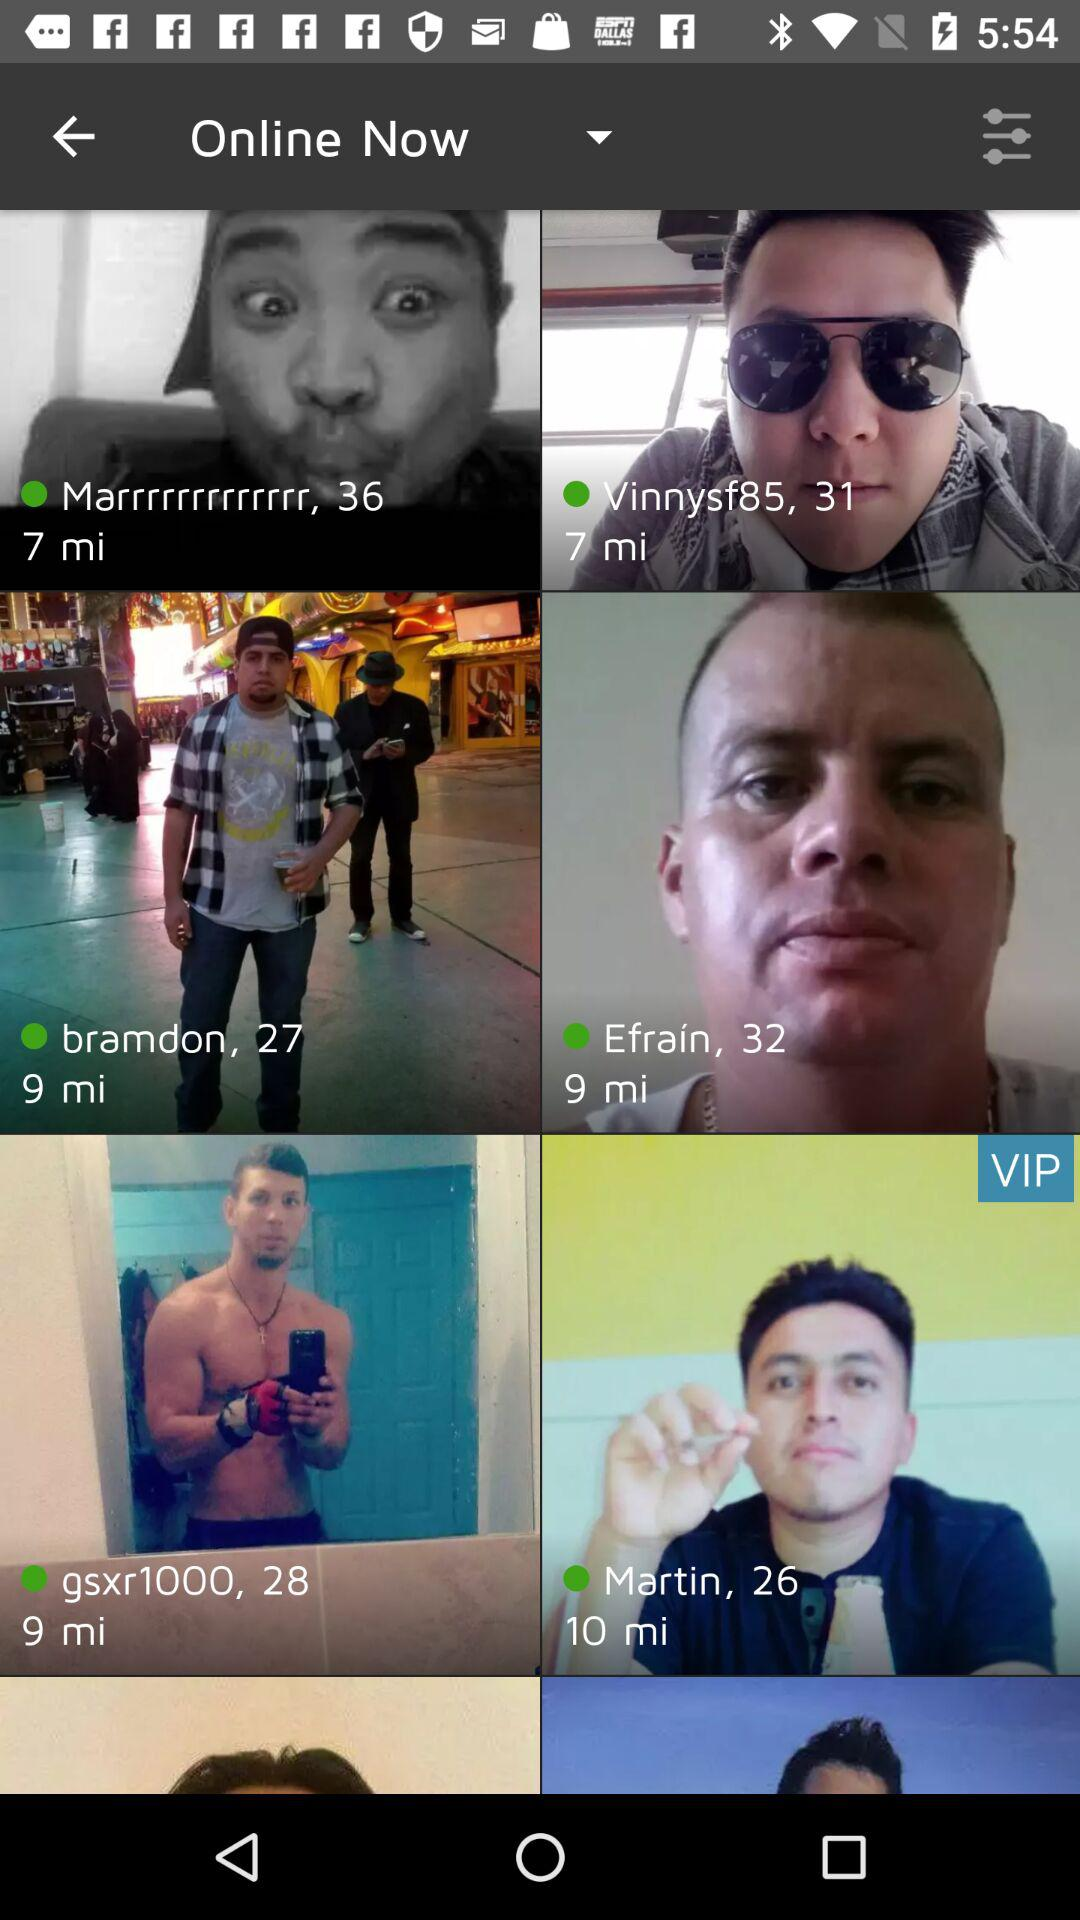What is the age of Martin? The age is 26 years. 